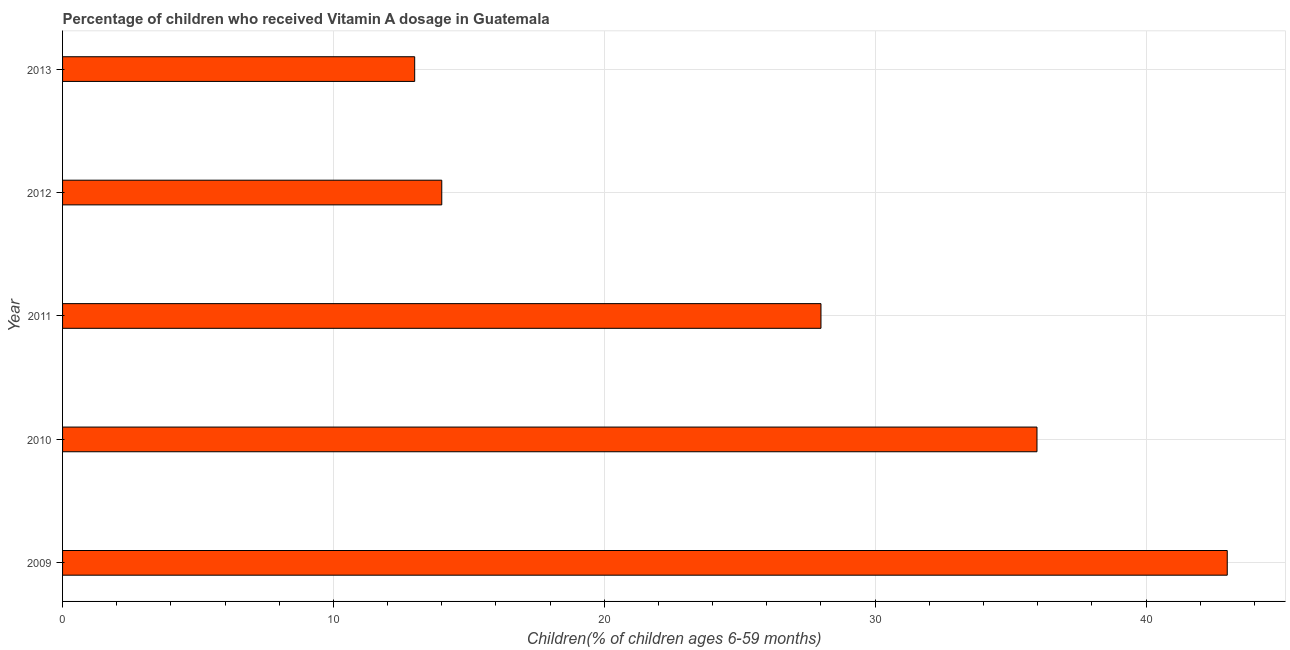Does the graph contain grids?
Offer a very short reply. Yes. What is the title of the graph?
Give a very brief answer. Percentage of children who received Vitamin A dosage in Guatemala. What is the label or title of the X-axis?
Your answer should be compact. Children(% of children ages 6-59 months). What is the label or title of the Y-axis?
Provide a short and direct response. Year. What is the vitamin a supplementation coverage rate in 2010?
Keep it short and to the point. 35.98. Across all years, what is the maximum vitamin a supplementation coverage rate?
Provide a succinct answer. 43. Across all years, what is the minimum vitamin a supplementation coverage rate?
Your answer should be compact. 13. What is the sum of the vitamin a supplementation coverage rate?
Make the answer very short. 133.98. What is the difference between the vitamin a supplementation coverage rate in 2011 and 2012?
Your response must be concise. 14. What is the average vitamin a supplementation coverage rate per year?
Give a very brief answer. 26.8. Do a majority of the years between 2009 and 2013 (inclusive) have vitamin a supplementation coverage rate greater than 42 %?
Your response must be concise. No. What is the ratio of the vitamin a supplementation coverage rate in 2012 to that in 2013?
Make the answer very short. 1.08. Is the difference between the vitamin a supplementation coverage rate in 2010 and 2013 greater than the difference between any two years?
Ensure brevity in your answer.  No. What is the difference between the highest and the second highest vitamin a supplementation coverage rate?
Your answer should be very brief. 7.03. Is the sum of the vitamin a supplementation coverage rate in 2010 and 2012 greater than the maximum vitamin a supplementation coverage rate across all years?
Offer a terse response. Yes. What is the difference between the highest and the lowest vitamin a supplementation coverage rate?
Offer a very short reply. 30. Are the values on the major ticks of X-axis written in scientific E-notation?
Keep it short and to the point. No. What is the Children(% of children ages 6-59 months) in 2009?
Your answer should be very brief. 43. What is the Children(% of children ages 6-59 months) of 2010?
Offer a very short reply. 35.98. What is the Children(% of children ages 6-59 months) of 2011?
Keep it short and to the point. 28. What is the Children(% of children ages 6-59 months) in 2013?
Your answer should be very brief. 13. What is the difference between the Children(% of children ages 6-59 months) in 2009 and 2010?
Give a very brief answer. 7.02. What is the difference between the Children(% of children ages 6-59 months) in 2009 and 2011?
Your response must be concise. 15. What is the difference between the Children(% of children ages 6-59 months) in 2010 and 2011?
Ensure brevity in your answer.  7.98. What is the difference between the Children(% of children ages 6-59 months) in 2010 and 2012?
Make the answer very short. 21.98. What is the difference between the Children(% of children ages 6-59 months) in 2010 and 2013?
Provide a succinct answer. 22.98. What is the difference between the Children(% of children ages 6-59 months) in 2011 and 2012?
Offer a terse response. 14. What is the ratio of the Children(% of children ages 6-59 months) in 2009 to that in 2010?
Offer a terse response. 1.2. What is the ratio of the Children(% of children ages 6-59 months) in 2009 to that in 2011?
Keep it short and to the point. 1.54. What is the ratio of the Children(% of children ages 6-59 months) in 2009 to that in 2012?
Provide a succinct answer. 3.07. What is the ratio of the Children(% of children ages 6-59 months) in 2009 to that in 2013?
Give a very brief answer. 3.31. What is the ratio of the Children(% of children ages 6-59 months) in 2010 to that in 2011?
Your answer should be compact. 1.28. What is the ratio of the Children(% of children ages 6-59 months) in 2010 to that in 2012?
Provide a short and direct response. 2.57. What is the ratio of the Children(% of children ages 6-59 months) in 2010 to that in 2013?
Provide a succinct answer. 2.77. What is the ratio of the Children(% of children ages 6-59 months) in 2011 to that in 2013?
Keep it short and to the point. 2.15. What is the ratio of the Children(% of children ages 6-59 months) in 2012 to that in 2013?
Offer a terse response. 1.08. 